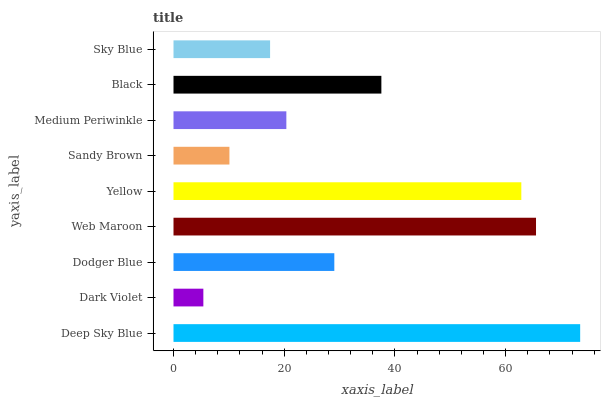Is Dark Violet the minimum?
Answer yes or no. Yes. Is Deep Sky Blue the maximum?
Answer yes or no. Yes. Is Dodger Blue the minimum?
Answer yes or no. No. Is Dodger Blue the maximum?
Answer yes or no. No. Is Dodger Blue greater than Dark Violet?
Answer yes or no. Yes. Is Dark Violet less than Dodger Blue?
Answer yes or no. Yes. Is Dark Violet greater than Dodger Blue?
Answer yes or no. No. Is Dodger Blue less than Dark Violet?
Answer yes or no. No. Is Dodger Blue the high median?
Answer yes or no. Yes. Is Dodger Blue the low median?
Answer yes or no. Yes. Is Medium Periwinkle the high median?
Answer yes or no. No. Is Deep Sky Blue the low median?
Answer yes or no. No. 